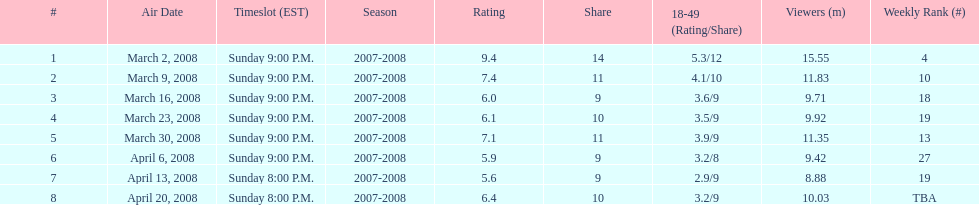What episode had the highest rating? March 2, 2008. 